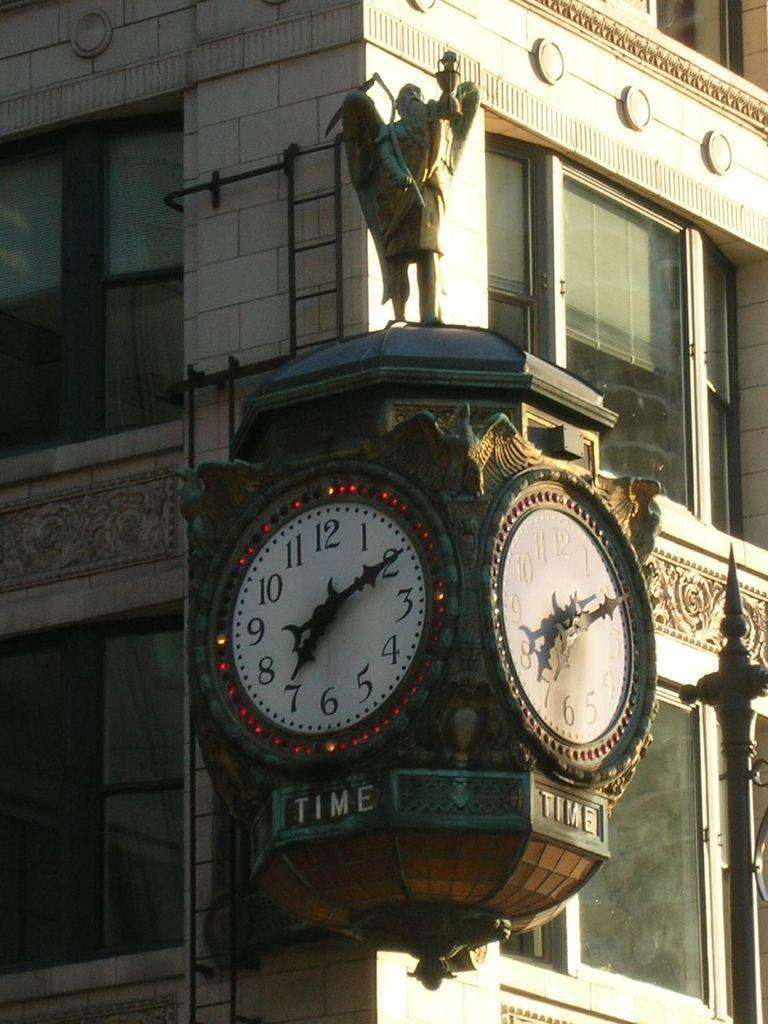<image>
Offer a succinct explanation of the picture presented. A clock sits on the corner wall of a building and is ornate and has two faces both showing it to be ten past seven. 